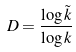<formula> <loc_0><loc_0><loc_500><loc_500>D = \frac { \log \tilde { k } } { \log k }</formula> 